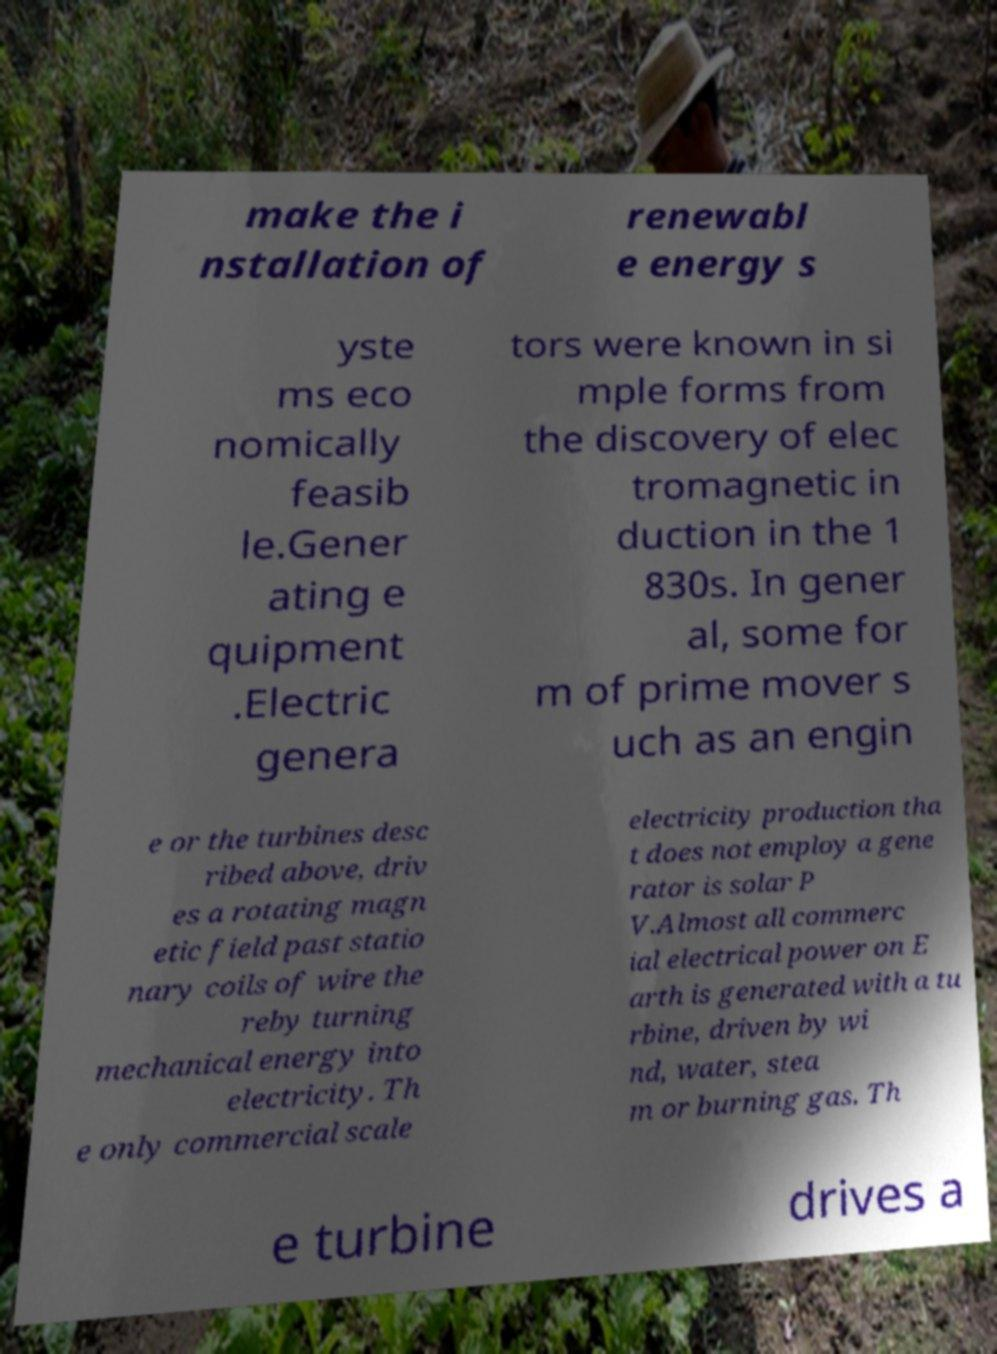Please identify and transcribe the text found in this image. make the i nstallation of renewabl e energy s yste ms eco nomically feasib le.Gener ating e quipment .Electric genera tors were known in si mple forms from the discovery of elec tromagnetic in duction in the 1 830s. In gener al, some for m of prime mover s uch as an engin e or the turbines desc ribed above, driv es a rotating magn etic field past statio nary coils of wire the reby turning mechanical energy into electricity. Th e only commercial scale electricity production tha t does not employ a gene rator is solar P V.Almost all commerc ial electrical power on E arth is generated with a tu rbine, driven by wi nd, water, stea m or burning gas. Th e turbine drives a 